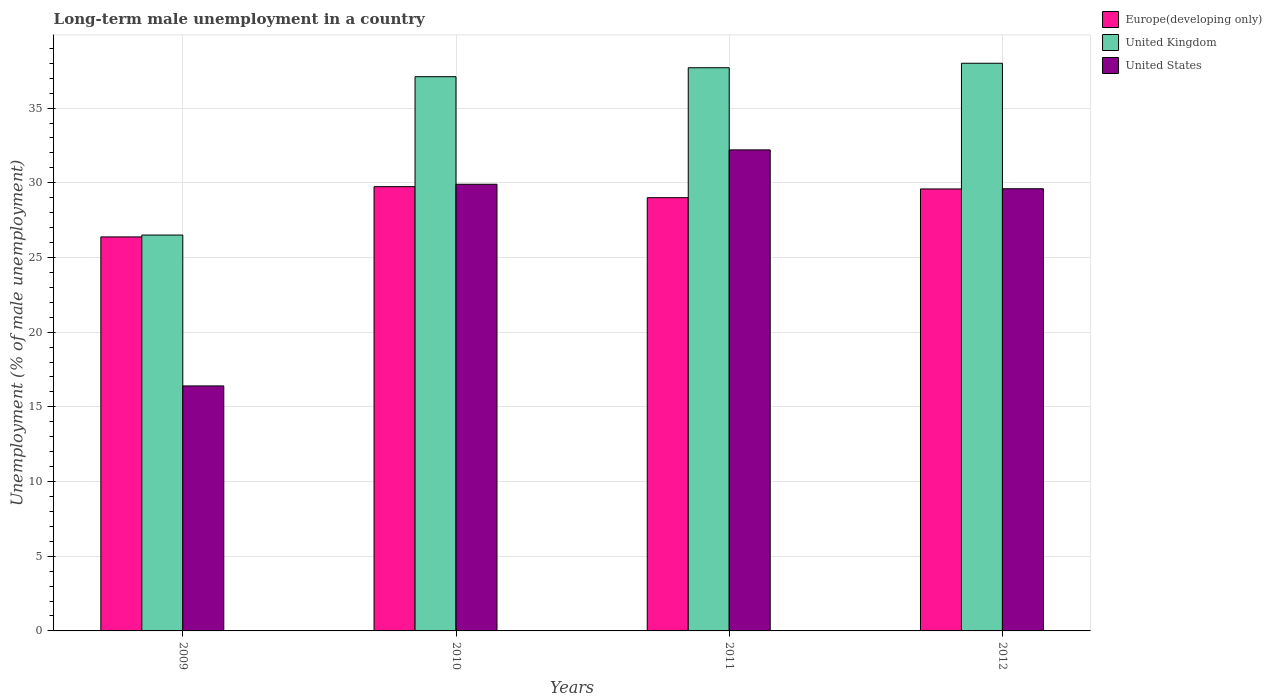How many different coloured bars are there?
Ensure brevity in your answer.  3. How many groups of bars are there?
Your answer should be compact. 4. Are the number of bars on each tick of the X-axis equal?
Your answer should be compact. Yes. How many bars are there on the 2nd tick from the left?
Ensure brevity in your answer.  3. How many bars are there on the 2nd tick from the right?
Your answer should be very brief. 3. What is the percentage of long-term unemployed male population in United Kingdom in 2010?
Your response must be concise. 37.1. Across all years, what is the maximum percentage of long-term unemployed male population in United Kingdom?
Provide a short and direct response. 38. Across all years, what is the minimum percentage of long-term unemployed male population in Europe(developing only)?
Ensure brevity in your answer.  26.38. In which year was the percentage of long-term unemployed male population in United Kingdom minimum?
Your answer should be compact. 2009. What is the total percentage of long-term unemployed male population in Europe(developing only) in the graph?
Provide a short and direct response. 114.7. What is the difference between the percentage of long-term unemployed male population in Europe(developing only) in 2009 and that in 2011?
Your answer should be very brief. -2.63. What is the difference between the percentage of long-term unemployed male population in Europe(developing only) in 2011 and the percentage of long-term unemployed male population in United Kingdom in 2010?
Give a very brief answer. -8.1. What is the average percentage of long-term unemployed male population in Europe(developing only) per year?
Provide a short and direct response. 28.68. In the year 2011, what is the difference between the percentage of long-term unemployed male population in Europe(developing only) and percentage of long-term unemployed male population in United Kingdom?
Your answer should be compact. -8.7. In how many years, is the percentage of long-term unemployed male population in United States greater than 22 %?
Your response must be concise. 3. What is the ratio of the percentage of long-term unemployed male population in Europe(developing only) in 2009 to that in 2010?
Give a very brief answer. 0.89. Is the percentage of long-term unemployed male population in United States in 2010 less than that in 2011?
Offer a very short reply. Yes. Is the difference between the percentage of long-term unemployed male population in Europe(developing only) in 2010 and 2011 greater than the difference between the percentage of long-term unemployed male population in United Kingdom in 2010 and 2011?
Your answer should be very brief. Yes. What is the difference between the highest and the second highest percentage of long-term unemployed male population in Europe(developing only)?
Give a very brief answer. 0.15. Is the sum of the percentage of long-term unemployed male population in United Kingdom in 2011 and 2012 greater than the maximum percentage of long-term unemployed male population in United States across all years?
Your answer should be very brief. Yes. What does the 3rd bar from the left in 2009 represents?
Offer a very short reply. United States. What does the 1st bar from the right in 2010 represents?
Give a very brief answer. United States. What is the difference between two consecutive major ticks on the Y-axis?
Give a very brief answer. 5. Are the values on the major ticks of Y-axis written in scientific E-notation?
Provide a short and direct response. No. Does the graph contain any zero values?
Provide a short and direct response. No. Where does the legend appear in the graph?
Provide a succinct answer. Top right. How are the legend labels stacked?
Your response must be concise. Vertical. What is the title of the graph?
Your answer should be very brief. Long-term male unemployment in a country. Does "Trinidad and Tobago" appear as one of the legend labels in the graph?
Your answer should be very brief. No. What is the label or title of the Y-axis?
Your response must be concise. Unemployment (% of male unemployment). What is the Unemployment (% of male unemployment) in Europe(developing only) in 2009?
Your answer should be very brief. 26.38. What is the Unemployment (% of male unemployment) of United Kingdom in 2009?
Give a very brief answer. 26.5. What is the Unemployment (% of male unemployment) in United States in 2009?
Your response must be concise. 16.4. What is the Unemployment (% of male unemployment) in Europe(developing only) in 2010?
Your answer should be compact. 29.74. What is the Unemployment (% of male unemployment) in United Kingdom in 2010?
Offer a terse response. 37.1. What is the Unemployment (% of male unemployment) of United States in 2010?
Keep it short and to the point. 29.9. What is the Unemployment (% of male unemployment) in Europe(developing only) in 2011?
Ensure brevity in your answer.  29. What is the Unemployment (% of male unemployment) of United Kingdom in 2011?
Make the answer very short. 37.7. What is the Unemployment (% of male unemployment) of United States in 2011?
Provide a succinct answer. 32.2. What is the Unemployment (% of male unemployment) in Europe(developing only) in 2012?
Provide a succinct answer. 29.59. What is the Unemployment (% of male unemployment) in United States in 2012?
Keep it short and to the point. 29.6. Across all years, what is the maximum Unemployment (% of male unemployment) in Europe(developing only)?
Offer a very short reply. 29.74. Across all years, what is the maximum Unemployment (% of male unemployment) of United Kingdom?
Give a very brief answer. 38. Across all years, what is the maximum Unemployment (% of male unemployment) in United States?
Your answer should be compact. 32.2. Across all years, what is the minimum Unemployment (% of male unemployment) of Europe(developing only)?
Offer a very short reply. 26.38. Across all years, what is the minimum Unemployment (% of male unemployment) in United States?
Your response must be concise. 16.4. What is the total Unemployment (% of male unemployment) in Europe(developing only) in the graph?
Offer a terse response. 114.7. What is the total Unemployment (% of male unemployment) of United Kingdom in the graph?
Offer a terse response. 139.3. What is the total Unemployment (% of male unemployment) of United States in the graph?
Provide a succinct answer. 108.1. What is the difference between the Unemployment (% of male unemployment) in Europe(developing only) in 2009 and that in 2010?
Your answer should be compact. -3.36. What is the difference between the Unemployment (% of male unemployment) in Europe(developing only) in 2009 and that in 2011?
Give a very brief answer. -2.63. What is the difference between the Unemployment (% of male unemployment) in United States in 2009 and that in 2011?
Your answer should be compact. -15.8. What is the difference between the Unemployment (% of male unemployment) of Europe(developing only) in 2009 and that in 2012?
Offer a terse response. -3.21. What is the difference between the Unemployment (% of male unemployment) in United Kingdom in 2009 and that in 2012?
Make the answer very short. -11.5. What is the difference between the Unemployment (% of male unemployment) in United States in 2009 and that in 2012?
Ensure brevity in your answer.  -13.2. What is the difference between the Unemployment (% of male unemployment) of Europe(developing only) in 2010 and that in 2011?
Your answer should be compact. 0.74. What is the difference between the Unemployment (% of male unemployment) of Europe(developing only) in 2010 and that in 2012?
Your answer should be compact. 0.15. What is the difference between the Unemployment (% of male unemployment) of United States in 2010 and that in 2012?
Give a very brief answer. 0.3. What is the difference between the Unemployment (% of male unemployment) of Europe(developing only) in 2011 and that in 2012?
Offer a very short reply. -0.58. What is the difference between the Unemployment (% of male unemployment) in United Kingdom in 2011 and that in 2012?
Give a very brief answer. -0.3. What is the difference between the Unemployment (% of male unemployment) in Europe(developing only) in 2009 and the Unemployment (% of male unemployment) in United Kingdom in 2010?
Offer a very short reply. -10.72. What is the difference between the Unemployment (% of male unemployment) in Europe(developing only) in 2009 and the Unemployment (% of male unemployment) in United States in 2010?
Offer a very short reply. -3.52. What is the difference between the Unemployment (% of male unemployment) in United Kingdom in 2009 and the Unemployment (% of male unemployment) in United States in 2010?
Ensure brevity in your answer.  -3.4. What is the difference between the Unemployment (% of male unemployment) of Europe(developing only) in 2009 and the Unemployment (% of male unemployment) of United Kingdom in 2011?
Provide a short and direct response. -11.32. What is the difference between the Unemployment (% of male unemployment) in Europe(developing only) in 2009 and the Unemployment (% of male unemployment) in United States in 2011?
Keep it short and to the point. -5.82. What is the difference between the Unemployment (% of male unemployment) in United Kingdom in 2009 and the Unemployment (% of male unemployment) in United States in 2011?
Provide a succinct answer. -5.7. What is the difference between the Unemployment (% of male unemployment) in Europe(developing only) in 2009 and the Unemployment (% of male unemployment) in United Kingdom in 2012?
Give a very brief answer. -11.62. What is the difference between the Unemployment (% of male unemployment) in Europe(developing only) in 2009 and the Unemployment (% of male unemployment) in United States in 2012?
Provide a short and direct response. -3.22. What is the difference between the Unemployment (% of male unemployment) in United Kingdom in 2009 and the Unemployment (% of male unemployment) in United States in 2012?
Your answer should be very brief. -3.1. What is the difference between the Unemployment (% of male unemployment) of Europe(developing only) in 2010 and the Unemployment (% of male unemployment) of United Kingdom in 2011?
Provide a short and direct response. -7.96. What is the difference between the Unemployment (% of male unemployment) of Europe(developing only) in 2010 and the Unemployment (% of male unemployment) of United States in 2011?
Offer a terse response. -2.46. What is the difference between the Unemployment (% of male unemployment) of United Kingdom in 2010 and the Unemployment (% of male unemployment) of United States in 2011?
Your response must be concise. 4.9. What is the difference between the Unemployment (% of male unemployment) in Europe(developing only) in 2010 and the Unemployment (% of male unemployment) in United Kingdom in 2012?
Give a very brief answer. -8.26. What is the difference between the Unemployment (% of male unemployment) of Europe(developing only) in 2010 and the Unemployment (% of male unemployment) of United States in 2012?
Your answer should be very brief. 0.14. What is the difference between the Unemployment (% of male unemployment) of Europe(developing only) in 2011 and the Unemployment (% of male unemployment) of United Kingdom in 2012?
Your answer should be compact. -9. What is the difference between the Unemployment (% of male unemployment) of Europe(developing only) in 2011 and the Unemployment (% of male unemployment) of United States in 2012?
Ensure brevity in your answer.  -0.6. What is the difference between the Unemployment (% of male unemployment) of United Kingdom in 2011 and the Unemployment (% of male unemployment) of United States in 2012?
Offer a terse response. 8.1. What is the average Unemployment (% of male unemployment) of Europe(developing only) per year?
Your answer should be compact. 28.68. What is the average Unemployment (% of male unemployment) of United Kingdom per year?
Make the answer very short. 34.83. What is the average Unemployment (% of male unemployment) of United States per year?
Your answer should be very brief. 27.02. In the year 2009, what is the difference between the Unemployment (% of male unemployment) of Europe(developing only) and Unemployment (% of male unemployment) of United Kingdom?
Offer a very short reply. -0.12. In the year 2009, what is the difference between the Unemployment (% of male unemployment) in Europe(developing only) and Unemployment (% of male unemployment) in United States?
Keep it short and to the point. 9.98. In the year 2010, what is the difference between the Unemployment (% of male unemployment) in Europe(developing only) and Unemployment (% of male unemployment) in United Kingdom?
Ensure brevity in your answer.  -7.36. In the year 2010, what is the difference between the Unemployment (% of male unemployment) of Europe(developing only) and Unemployment (% of male unemployment) of United States?
Keep it short and to the point. -0.16. In the year 2011, what is the difference between the Unemployment (% of male unemployment) in Europe(developing only) and Unemployment (% of male unemployment) in United Kingdom?
Ensure brevity in your answer.  -8.7. In the year 2011, what is the difference between the Unemployment (% of male unemployment) in Europe(developing only) and Unemployment (% of male unemployment) in United States?
Your answer should be compact. -3.2. In the year 2012, what is the difference between the Unemployment (% of male unemployment) in Europe(developing only) and Unemployment (% of male unemployment) in United Kingdom?
Your response must be concise. -8.41. In the year 2012, what is the difference between the Unemployment (% of male unemployment) of Europe(developing only) and Unemployment (% of male unemployment) of United States?
Ensure brevity in your answer.  -0.01. What is the ratio of the Unemployment (% of male unemployment) of Europe(developing only) in 2009 to that in 2010?
Make the answer very short. 0.89. What is the ratio of the Unemployment (% of male unemployment) in United Kingdom in 2009 to that in 2010?
Your response must be concise. 0.71. What is the ratio of the Unemployment (% of male unemployment) of United States in 2009 to that in 2010?
Your answer should be compact. 0.55. What is the ratio of the Unemployment (% of male unemployment) in Europe(developing only) in 2009 to that in 2011?
Ensure brevity in your answer.  0.91. What is the ratio of the Unemployment (% of male unemployment) in United Kingdom in 2009 to that in 2011?
Your response must be concise. 0.7. What is the ratio of the Unemployment (% of male unemployment) of United States in 2009 to that in 2011?
Ensure brevity in your answer.  0.51. What is the ratio of the Unemployment (% of male unemployment) of Europe(developing only) in 2009 to that in 2012?
Provide a succinct answer. 0.89. What is the ratio of the Unemployment (% of male unemployment) in United Kingdom in 2009 to that in 2012?
Ensure brevity in your answer.  0.7. What is the ratio of the Unemployment (% of male unemployment) of United States in 2009 to that in 2012?
Your answer should be very brief. 0.55. What is the ratio of the Unemployment (% of male unemployment) of Europe(developing only) in 2010 to that in 2011?
Give a very brief answer. 1.03. What is the ratio of the Unemployment (% of male unemployment) in United Kingdom in 2010 to that in 2011?
Keep it short and to the point. 0.98. What is the ratio of the Unemployment (% of male unemployment) in United Kingdom in 2010 to that in 2012?
Your answer should be very brief. 0.98. What is the ratio of the Unemployment (% of male unemployment) of Europe(developing only) in 2011 to that in 2012?
Make the answer very short. 0.98. What is the ratio of the Unemployment (% of male unemployment) of United States in 2011 to that in 2012?
Make the answer very short. 1.09. What is the difference between the highest and the second highest Unemployment (% of male unemployment) of Europe(developing only)?
Give a very brief answer. 0.15. What is the difference between the highest and the lowest Unemployment (% of male unemployment) of Europe(developing only)?
Provide a succinct answer. 3.36. What is the difference between the highest and the lowest Unemployment (% of male unemployment) in United Kingdom?
Provide a short and direct response. 11.5. 